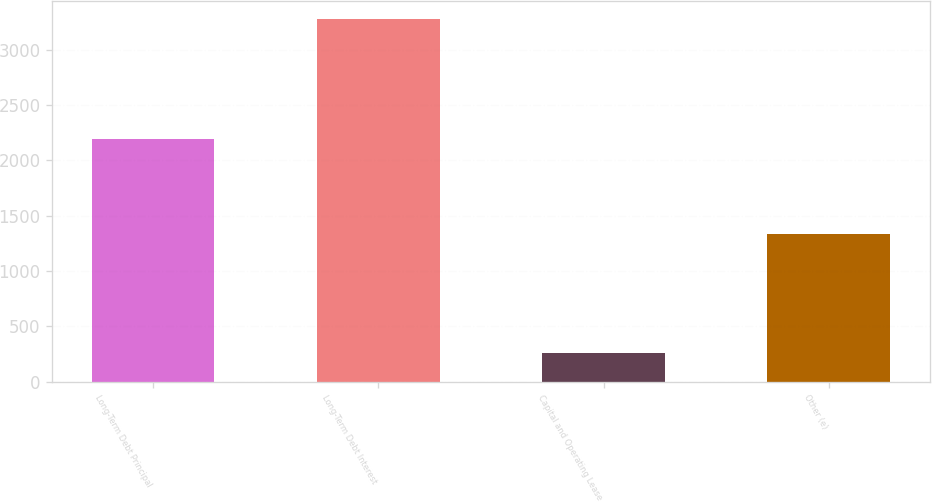<chart> <loc_0><loc_0><loc_500><loc_500><bar_chart><fcel>Long-Term Debt Principal<fcel>Long-Term Debt Interest<fcel>Capital and Operating Lease<fcel>Other (e)<nl><fcel>2197<fcel>3275<fcel>259<fcel>1334<nl></chart> 